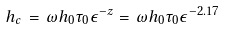Convert formula to latex. <formula><loc_0><loc_0><loc_500><loc_500>h _ { c } \, = \, \omega h _ { 0 } \tau _ { 0 } \epsilon ^ { - z } = \, \omega h _ { 0 } \tau _ { 0 } \epsilon ^ { - 2 . 1 7 }</formula> 